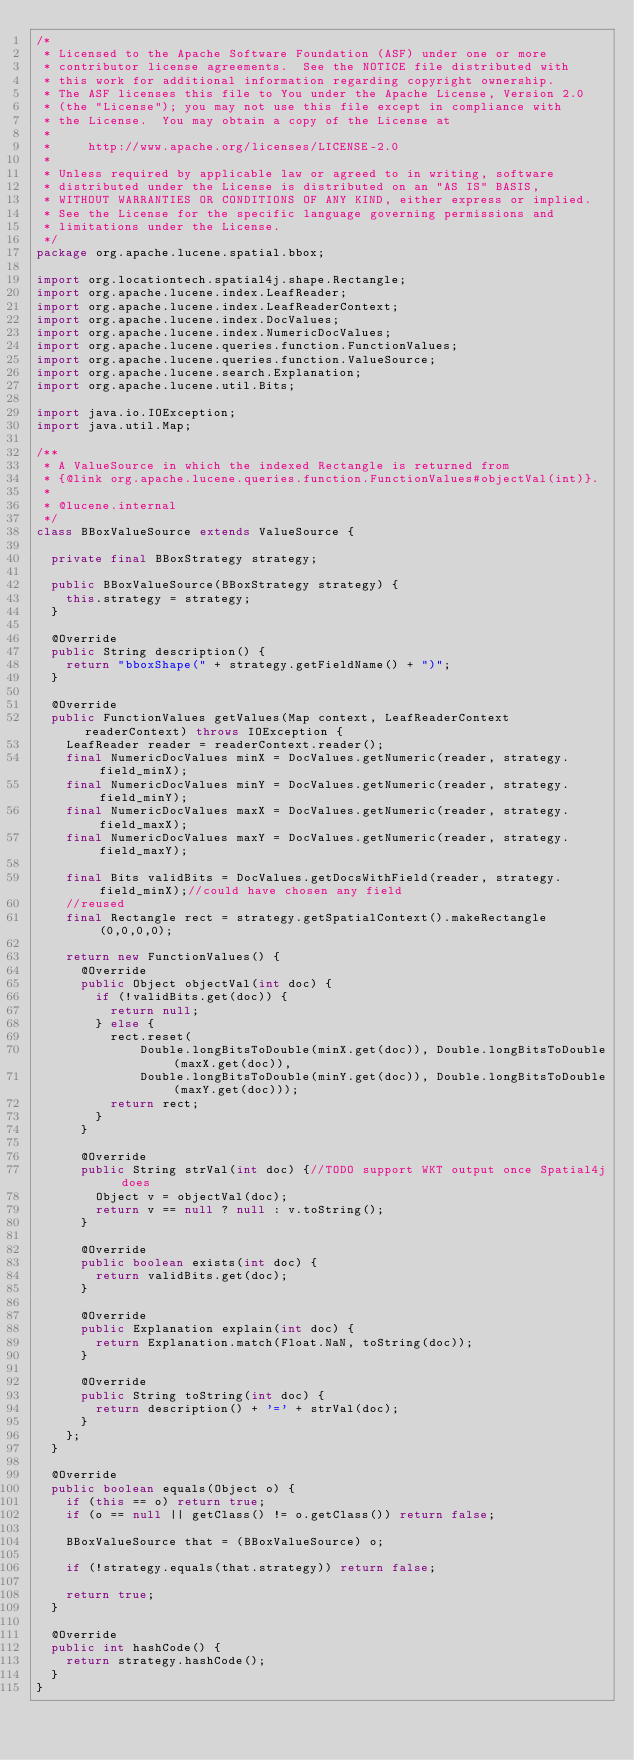<code> <loc_0><loc_0><loc_500><loc_500><_Java_>/*
 * Licensed to the Apache Software Foundation (ASF) under one or more
 * contributor license agreements.  See the NOTICE file distributed with
 * this work for additional information regarding copyright ownership.
 * The ASF licenses this file to You under the Apache License, Version 2.0
 * (the "License"); you may not use this file except in compliance with
 * the License.  You may obtain a copy of the License at
 *
 *     http://www.apache.org/licenses/LICENSE-2.0
 *
 * Unless required by applicable law or agreed to in writing, software
 * distributed under the License is distributed on an "AS IS" BASIS,
 * WITHOUT WARRANTIES OR CONDITIONS OF ANY KIND, either express or implied.
 * See the License for the specific language governing permissions and
 * limitations under the License.
 */
package org.apache.lucene.spatial.bbox;

import org.locationtech.spatial4j.shape.Rectangle;
import org.apache.lucene.index.LeafReader;
import org.apache.lucene.index.LeafReaderContext;
import org.apache.lucene.index.DocValues;
import org.apache.lucene.index.NumericDocValues;
import org.apache.lucene.queries.function.FunctionValues;
import org.apache.lucene.queries.function.ValueSource;
import org.apache.lucene.search.Explanation;
import org.apache.lucene.util.Bits;

import java.io.IOException;
import java.util.Map;

/**
 * A ValueSource in which the indexed Rectangle is returned from
 * {@link org.apache.lucene.queries.function.FunctionValues#objectVal(int)}.
 *
 * @lucene.internal
 */
class BBoxValueSource extends ValueSource {

  private final BBoxStrategy strategy;

  public BBoxValueSource(BBoxStrategy strategy) {
    this.strategy = strategy;
  }

  @Override
  public String description() {
    return "bboxShape(" + strategy.getFieldName() + ")";
  }

  @Override
  public FunctionValues getValues(Map context, LeafReaderContext readerContext) throws IOException {
    LeafReader reader = readerContext.reader();
    final NumericDocValues minX = DocValues.getNumeric(reader, strategy.field_minX);
    final NumericDocValues minY = DocValues.getNumeric(reader, strategy.field_minY);
    final NumericDocValues maxX = DocValues.getNumeric(reader, strategy.field_maxX);
    final NumericDocValues maxY = DocValues.getNumeric(reader, strategy.field_maxY);

    final Bits validBits = DocValues.getDocsWithField(reader, strategy.field_minX);//could have chosen any field
    //reused
    final Rectangle rect = strategy.getSpatialContext().makeRectangle(0,0,0,0);

    return new FunctionValues() {
      @Override
      public Object objectVal(int doc) {
        if (!validBits.get(doc)) {
          return null;
        } else {
          rect.reset(
              Double.longBitsToDouble(minX.get(doc)), Double.longBitsToDouble(maxX.get(doc)),
              Double.longBitsToDouble(minY.get(doc)), Double.longBitsToDouble(maxY.get(doc)));
          return rect;
        }
      }

      @Override
      public String strVal(int doc) {//TODO support WKT output once Spatial4j does
        Object v = objectVal(doc);
        return v == null ? null : v.toString();
      }

      @Override
      public boolean exists(int doc) {
        return validBits.get(doc);
      }

      @Override
      public Explanation explain(int doc) {
        return Explanation.match(Float.NaN, toString(doc));
      }

      @Override
      public String toString(int doc) {
        return description() + '=' + strVal(doc);
      }
    };
  }

  @Override
  public boolean equals(Object o) {
    if (this == o) return true;
    if (o == null || getClass() != o.getClass()) return false;

    BBoxValueSource that = (BBoxValueSource) o;

    if (!strategy.equals(that.strategy)) return false;

    return true;
  }

  @Override
  public int hashCode() {
    return strategy.hashCode();
  }
}
</code> 